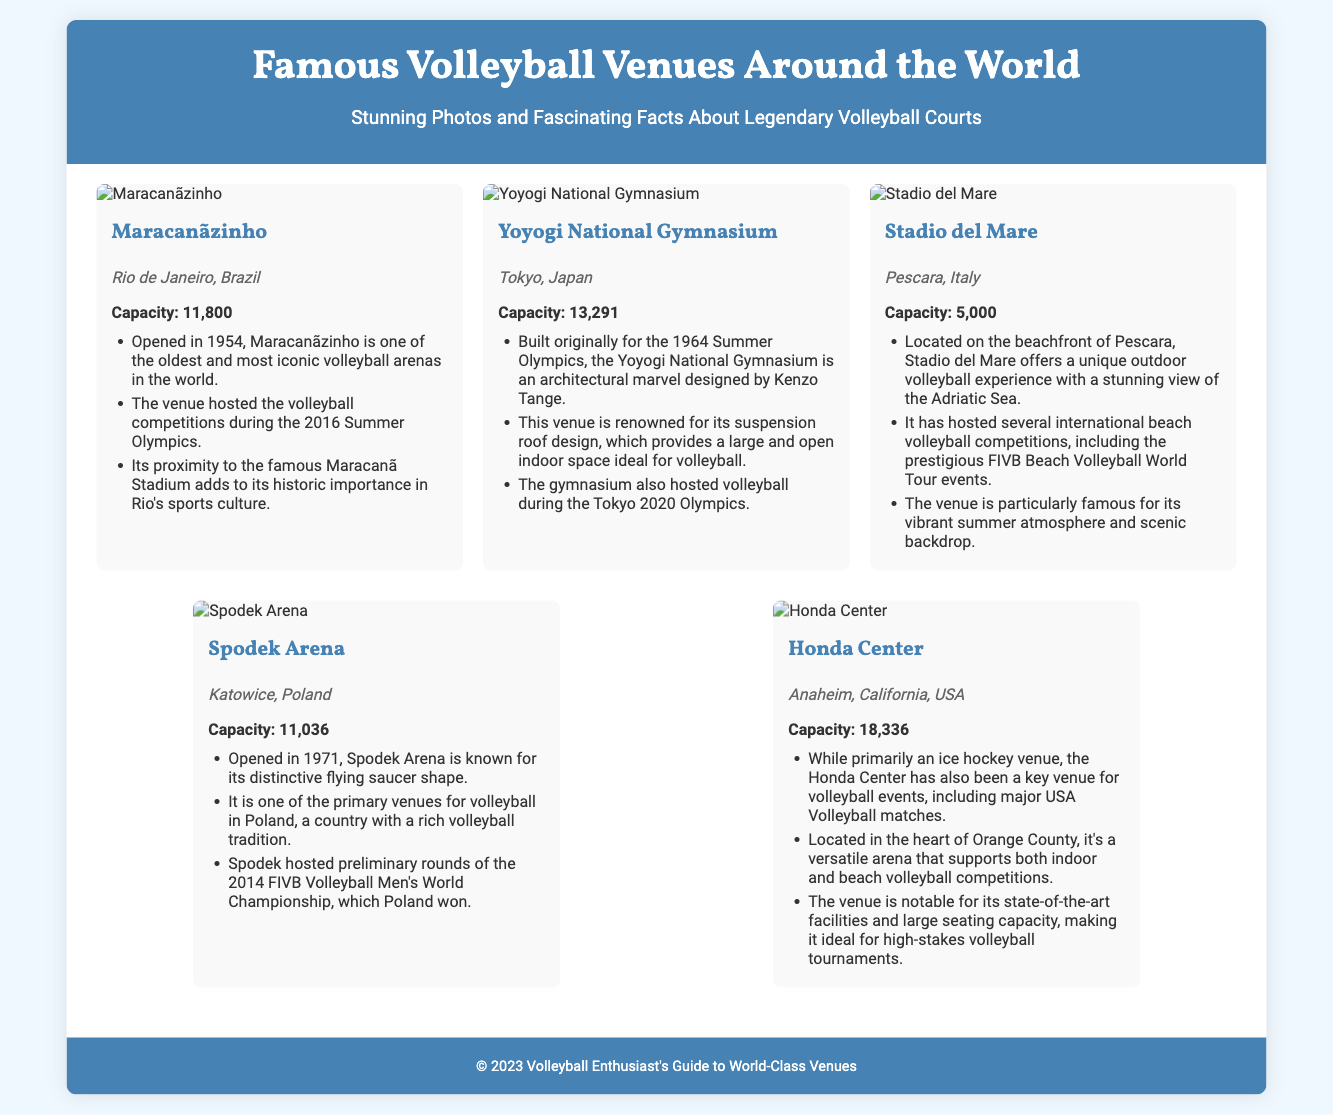What is the capacity of Maracanãzinho? The capacity of Maracanãzinho is provided in the document as 11,800.
Answer: 11,800 Where is the Yoyogi National Gymnasium located? The document mentions the location of the Yoyogi National Gymnasium as Tokyo, Japan.
Answer: Tokyo, Japan When was Stadio del Mare opened? The document does not explicitly provide an opening year for Stadio del Mare, therefore this question cannot be directly answered based on the available information.
Answer: Not specified What is unique about the roof of Yoyogi National Gymnasium? The document states that the Yoyogi National Gymnasium is renowned for its suspension roof design.
Answer: Suspension roof design Which venue hosted volleyball during the 2016 Summer Olympics? The document specifically mentions that Maracanãzinho hosted volleyball at the 2016 Summer Olympics.
Answer: Maracanãzinho What is the seating capacity of Honda Center? The seating capacity of Honda Center is listed as 18,336 in the document.
Answer: 18,336 What is the notable feature of Spodek Arena? The document describes Spodek Arena as known for its distinctive flying saucer shape.
Answer: Distinctive flying saucer shape Which venue is famous for its vibrant summer atmosphere? According to the document, Stadio del Mare is particularly famous for its vibrant summer atmosphere.
Answer: Stadio del Mare 